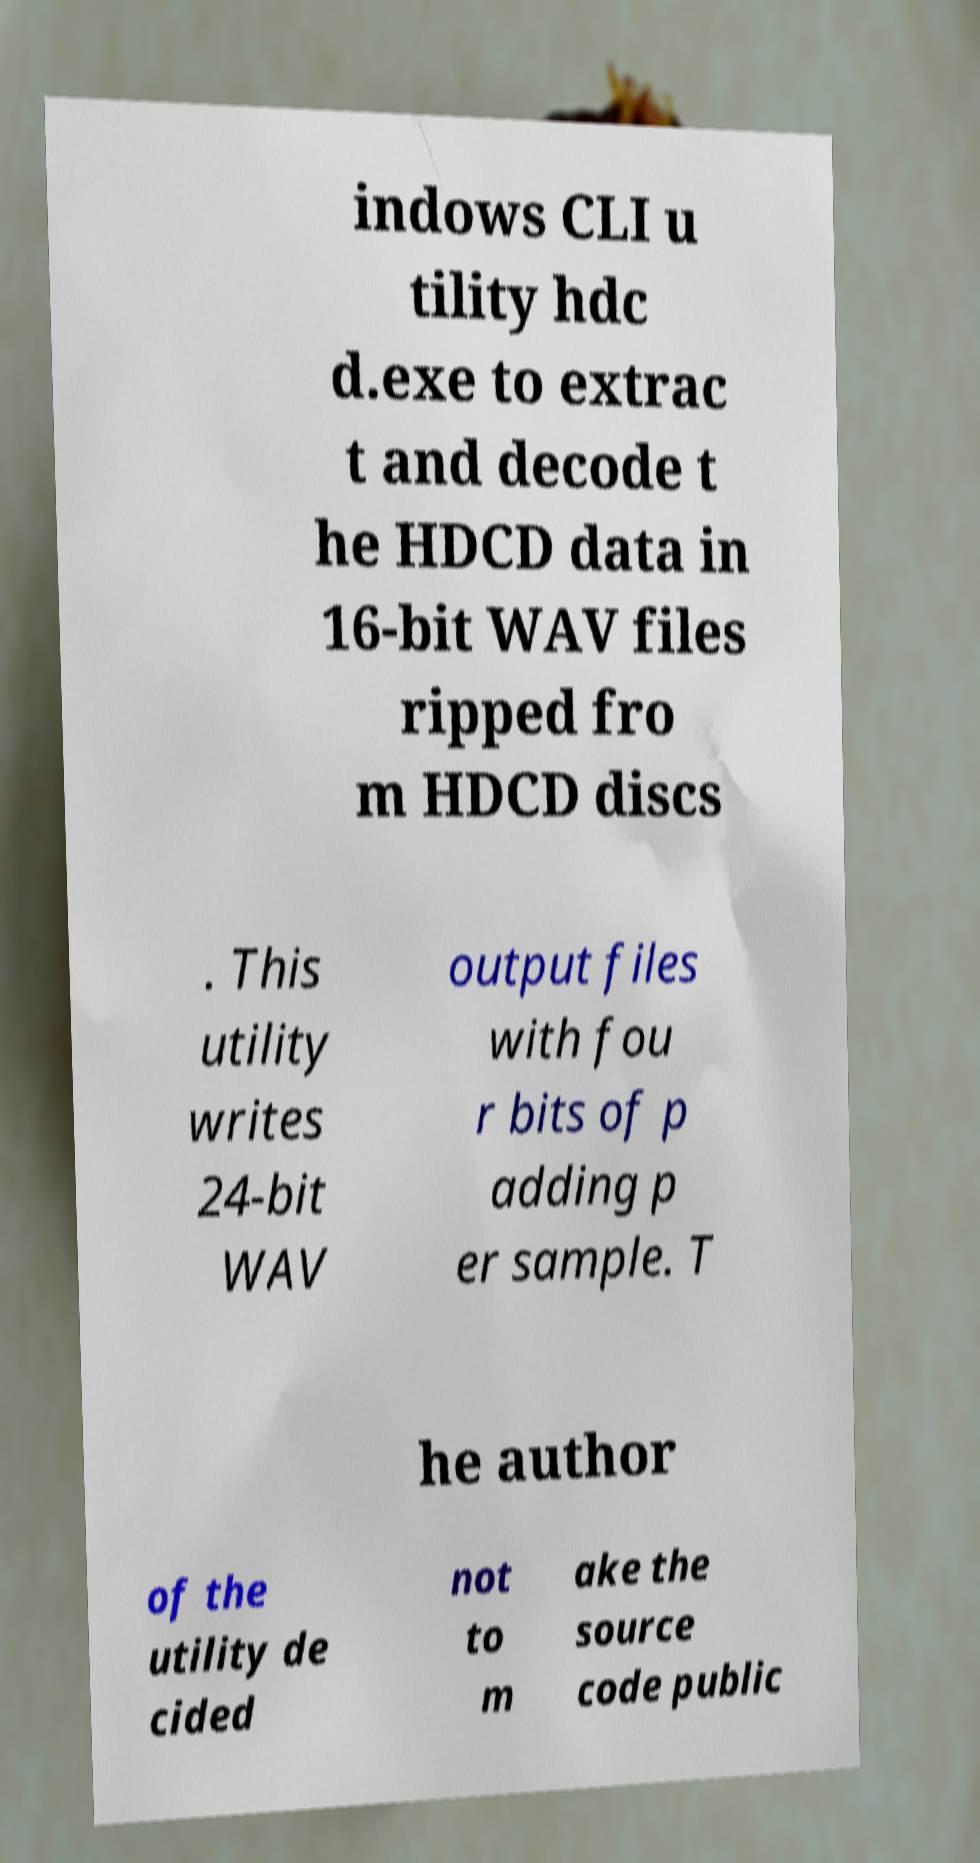Could you assist in decoding the text presented in this image and type it out clearly? indows CLI u tility hdc d.exe to extrac t and decode t he HDCD data in 16-bit WAV files ripped fro m HDCD discs . This utility writes 24-bit WAV output files with fou r bits of p adding p er sample. T he author of the utility de cided not to m ake the source code public 